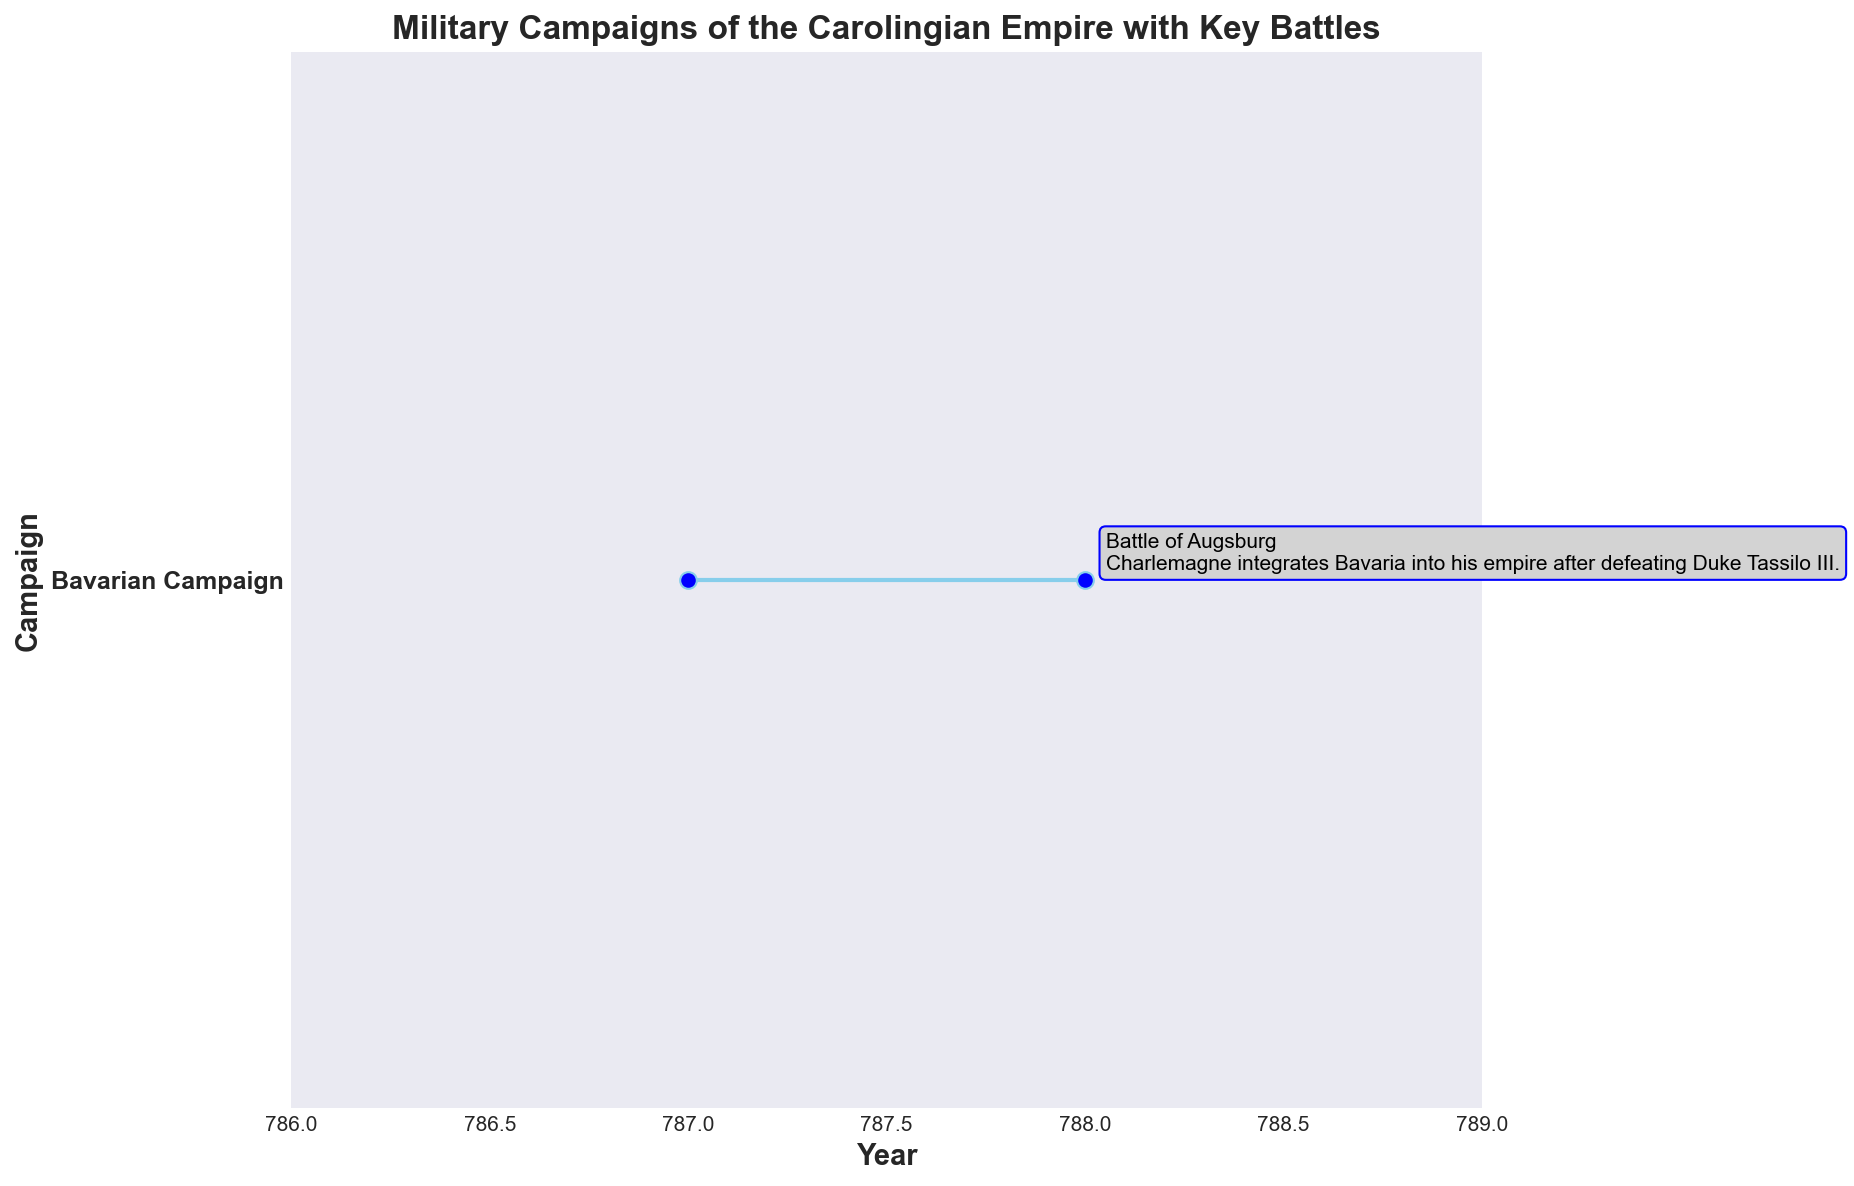What is the duration of the Bavarian Campaign? To find the duration, subtract the Start Year from the End Year: 788 - 787 = 1 year
Answer: 1 year Which campaign is displayed in the figure? The figure only shows the Bavarian Campaign as it is the only data present in the dataset
Answer: Bavarian Campaign What key battle took place during the Bavarian Campaign? The figure annotates the key battle as the Battle of Augsburg
Answer: Battle of Augsburg Compare the Start and End Years of the Bavarian Campaign. Is the duration more than 1 year? The Start Year is 787 and the End Year is 788. By subtracting 787 from 788, we see that the duration is 1 year, which is not more than 1 year
Answer: No, it is not more than 1 year How many campaigns are included in the figure? There is one campaign listed in the dataset and shown on the figure: Bavarian Campaign
Answer: 1 campaign Which colors are used to mark the campaign line and the key battles? The campaign line is marked with sky blue, and the key battles are annotated using blue and light gray colors for readability
Answer: Sky blue and blue-light gray What is the main annotation for the Bavarian Campaign? The annotation reads: "Charlemagne integrates Bavaria into his empire after defeating Duke Tassilo III." This can be seen directly on the figure
Answer: Charlemagne integrates Bavaria into his empire after defeating Duke Tassilo III Is there any campaign that started before 787? Based on the data and the figure shown, there is no campaign listed that started before 787
Answer: No What does the figure title indicate about the campaigns? The title "Military Campaigns of the Carolingian Empire with Key Battles" suggests that the figure focuses on the military campaigns and annotated key battles of the Carolingian Empire
Answer: Focus on military campaigns and key battles What annotation is associated with the Battle of Augsburg? The annotation associated is "Charlemagne integrates Bavaria into his empire after defeating Duke Tassilo III" as displayed on the figure
Answer: Charlemagne integrates Bavaria into his empire after defeating Duke Tassilo III 